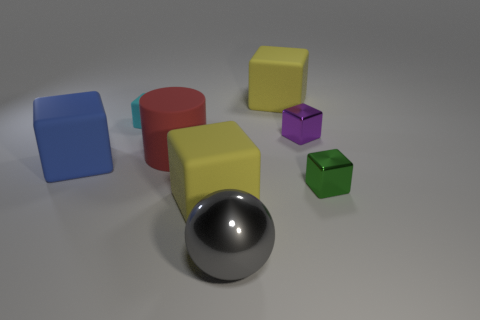There is a rubber thing on the right side of the yellow matte thing in front of the small metal block that is in front of the blue cube; what is its color?
Provide a short and direct response. Yellow. What is the size of the yellow thing on the left side of the big cube that is behind the large red cylinder?
Your answer should be very brief. Large. The big thing that is behind the gray metallic sphere and in front of the tiny green metallic cube is made of what material?
Offer a very short reply. Rubber. Does the rubber cylinder have the same size as the yellow block that is behind the green thing?
Your answer should be very brief. Yes. Is there a green metal cube?
Give a very brief answer. Yes. There is a green thing that is the same shape as the small cyan matte object; what is it made of?
Your answer should be compact. Metal. How big is the yellow block on the right side of the large yellow rubber object left of the big rubber cube behind the blue matte cube?
Make the answer very short. Large. There is a purple shiny cube; are there any large cylinders to the left of it?
Your answer should be very brief. Yes. What is the size of the gray thing that is the same material as the green thing?
Ensure brevity in your answer.  Large. How many red matte things are the same shape as the green object?
Provide a short and direct response. 0. 